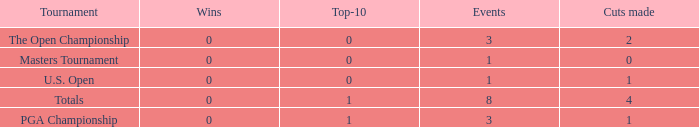Could you help me parse every detail presented in this table? {'header': ['Tournament', 'Wins', 'Top-10', 'Events', 'Cuts made'], 'rows': [['The Open Championship', '0', '0', '3', '2'], ['Masters Tournament', '0', '0', '1', '0'], ['U.S. Open', '0', '0', '1', '1'], ['Totals', '0', '1', '8', '4'], ['PGA Championship', '0', '1', '3', '1']]} For events with under 3 times played and fewer than 1 cut made, what is the total number of top-10 finishes? 1.0. 